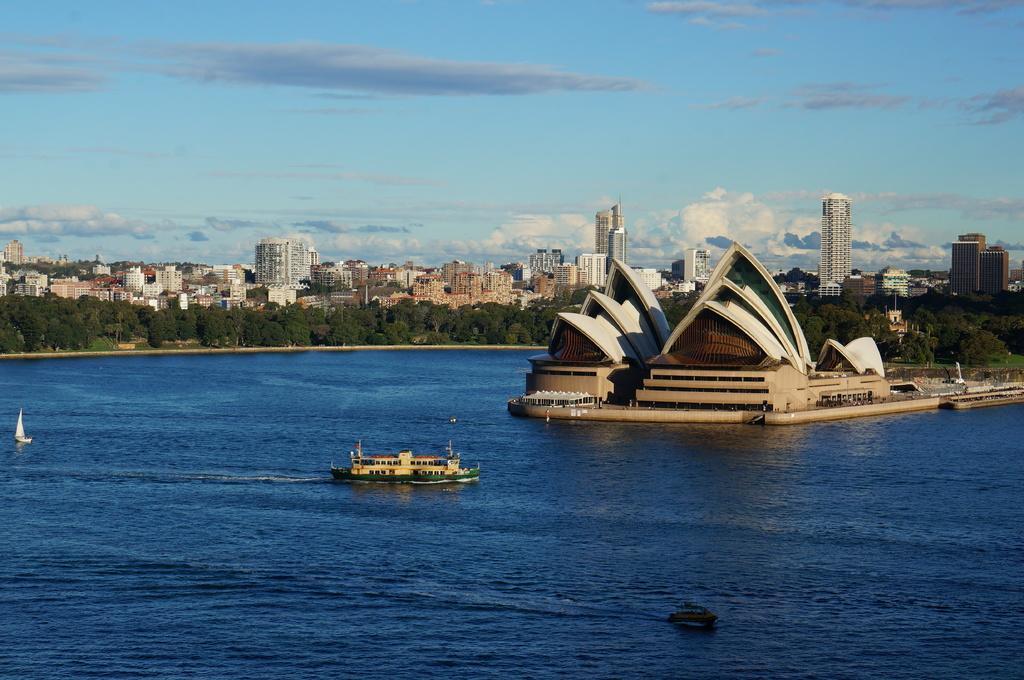Describe this image in one or two sentences. This picture shows building in the water and we see a ship and couple of boats in the water and we see trees and buildings and a blue cloudy Sky. 